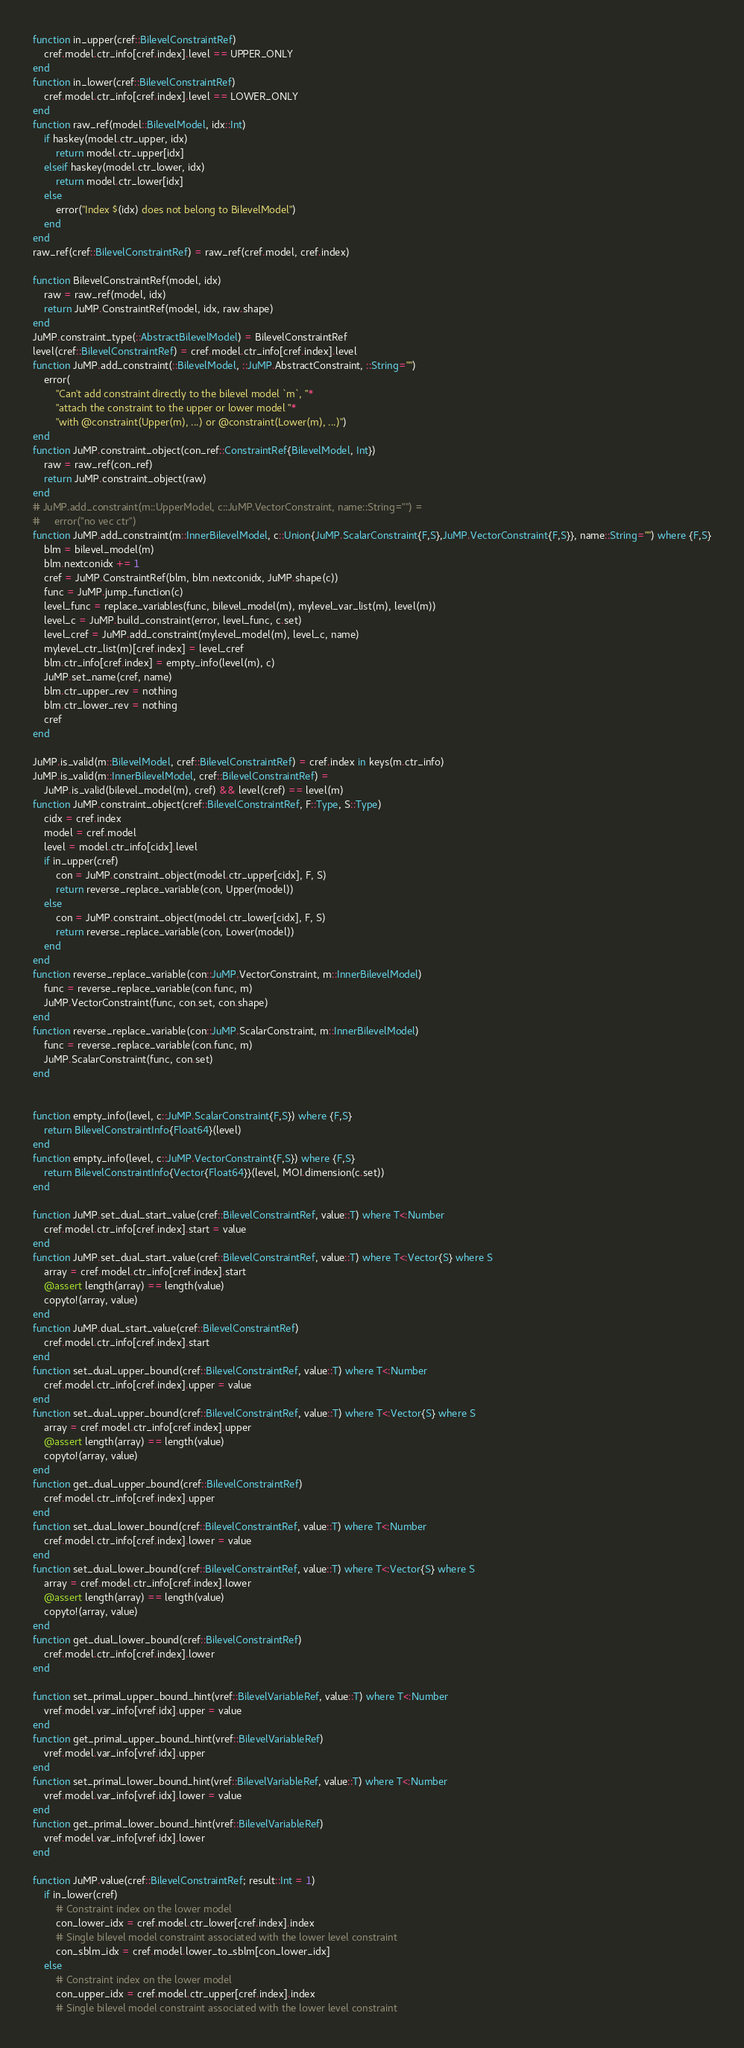<code> <loc_0><loc_0><loc_500><loc_500><_Julia_>function in_upper(cref::BilevelConstraintRef)
    cref.model.ctr_info[cref.index].level == UPPER_ONLY
end
function in_lower(cref::BilevelConstraintRef)
    cref.model.ctr_info[cref.index].level == LOWER_ONLY
end
function raw_ref(model::BilevelModel, idx::Int)
    if haskey(model.ctr_upper, idx)
        return model.ctr_upper[idx]
    elseif haskey(model.ctr_lower, idx)
        return model.ctr_lower[idx]
    else
        error("Index $(idx) does not belong to BilevelModel")
    end
end
raw_ref(cref::BilevelConstraintRef) = raw_ref(cref.model, cref.index)

function BilevelConstraintRef(model, idx)
    raw = raw_ref(model, idx)
    return JuMP.ConstraintRef(model, idx, raw.shape)
end
JuMP.constraint_type(::AbstractBilevelModel) = BilevelConstraintRef
level(cref::BilevelConstraintRef) = cref.model.ctr_info[cref.index].level
function JuMP.add_constraint(::BilevelModel, ::JuMP.AbstractConstraint, ::String="")
    error(
        "Can't add constraint directly to the bilevel model `m`, "*
        "attach the constraint to the upper or lower model "*
        "with @constraint(Upper(m), ...) or @constraint(Lower(m), ...)")
end
function JuMP.constraint_object(con_ref::ConstraintRef{BilevelModel, Int})
    raw = raw_ref(con_ref)
    return JuMP.constraint_object(raw)
end
# JuMP.add_constraint(m::UpperModel, c::JuMP.VectorConstraint, name::String="") =
#     error("no vec ctr")
function JuMP.add_constraint(m::InnerBilevelModel, c::Union{JuMP.ScalarConstraint{F,S},JuMP.VectorConstraint{F,S}}, name::String="") where {F,S}
    blm = bilevel_model(m)
    blm.nextconidx += 1
    cref = JuMP.ConstraintRef(blm, blm.nextconidx, JuMP.shape(c))
    func = JuMP.jump_function(c)
    level_func = replace_variables(func, bilevel_model(m), mylevel_var_list(m), level(m))
    level_c = JuMP.build_constraint(error, level_func, c.set)
    level_cref = JuMP.add_constraint(mylevel_model(m), level_c, name)
    mylevel_ctr_list(m)[cref.index] = level_cref
    blm.ctr_info[cref.index] = empty_info(level(m), c)
    JuMP.set_name(cref, name)
    blm.ctr_upper_rev = nothing
    blm.ctr_lower_rev = nothing
    cref
end

JuMP.is_valid(m::BilevelModel, cref::BilevelConstraintRef) = cref.index in keys(m.ctr_info)
JuMP.is_valid(m::InnerBilevelModel, cref::BilevelConstraintRef) =
    JuMP.is_valid(bilevel_model(m), cref) && level(cref) == level(m)
function JuMP.constraint_object(cref::BilevelConstraintRef, F::Type, S::Type)
    cidx = cref.index
    model = cref.model
    level = model.ctr_info[cidx].level
    if in_upper(cref)
        con = JuMP.constraint_object(model.ctr_upper[cidx], F, S)
        return reverse_replace_variable(con, Upper(model))
    else
        con = JuMP.constraint_object(model.ctr_lower[cidx], F, S)
        return reverse_replace_variable(con, Lower(model))
    end
end
function reverse_replace_variable(con::JuMP.VectorConstraint, m::InnerBilevelModel)
    func = reverse_replace_variable(con.func, m)
    JuMP.VectorConstraint(func, con.set, con.shape)
end
function reverse_replace_variable(con::JuMP.ScalarConstraint, m::InnerBilevelModel)
    func = reverse_replace_variable(con.func, m)
    JuMP.ScalarConstraint(func, con.set)
end


function empty_info(level, c::JuMP.ScalarConstraint{F,S}) where {F,S}
    return BilevelConstraintInfo{Float64}(level)
end
function empty_info(level, c::JuMP.VectorConstraint{F,S}) where {F,S}
    return BilevelConstraintInfo{Vector{Float64}}(level, MOI.dimension(c.set))
end

function JuMP.set_dual_start_value(cref::BilevelConstraintRef, value::T) where T<:Number
    cref.model.ctr_info[cref.index].start = value
end
function JuMP.set_dual_start_value(cref::BilevelConstraintRef, value::T) where T<:Vector{S} where S
    array = cref.model.ctr_info[cref.index].start
    @assert length(array) == length(value)
    copyto!(array, value)
end
function JuMP.dual_start_value(cref::BilevelConstraintRef)
    cref.model.ctr_info[cref.index].start
end
function set_dual_upper_bound(cref::BilevelConstraintRef, value::T) where T<:Number
    cref.model.ctr_info[cref.index].upper = value
end
function set_dual_upper_bound(cref::BilevelConstraintRef, value::T) where T<:Vector{S} where S
    array = cref.model.ctr_info[cref.index].upper
    @assert length(array) == length(value)
    copyto!(array, value)
end
function get_dual_upper_bound(cref::BilevelConstraintRef)
    cref.model.ctr_info[cref.index].upper
end
function set_dual_lower_bound(cref::BilevelConstraintRef, value::T) where T<:Number
    cref.model.ctr_info[cref.index].lower = value
end
function set_dual_lower_bound(cref::BilevelConstraintRef, value::T) where T<:Vector{S} where S
    array = cref.model.ctr_info[cref.index].lower
    @assert length(array) == length(value)
    copyto!(array, value)
end
function get_dual_lower_bound(cref::BilevelConstraintRef)
    cref.model.ctr_info[cref.index].lower
end

function set_primal_upper_bound_hint(vref::BilevelVariableRef, value::T) where T<:Number
    vref.model.var_info[vref.idx].upper = value
end
function get_primal_upper_bound_hint(vref::BilevelVariableRef)
    vref.model.var_info[vref.idx].upper
end
function set_primal_lower_bound_hint(vref::BilevelVariableRef, value::T) where T<:Number
    vref.model.var_info[vref.idx].lower = value
end
function get_primal_lower_bound_hint(vref::BilevelVariableRef)
    vref.model.var_info[vref.idx].lower
end

function JuMP.value(cref::BilevelConstraintRef; result::Int = 1)
    if in_lower(cref)
        # Constraint index on the lower model
        con_lower_idx = cref.model.ctr_lower[cref.index].index
        # Single bilevel model constraint associated with the lower level constraint
        con_sblm_idx = cref.model.lower_to_sblm[con_lower_idx]
    else
        # Constraint index on the lower model
        con_upper_idx = cref.model.ctr_upper[cref.index].index
        # Single bilevel model constraint associated with the lower level constraint</code> 